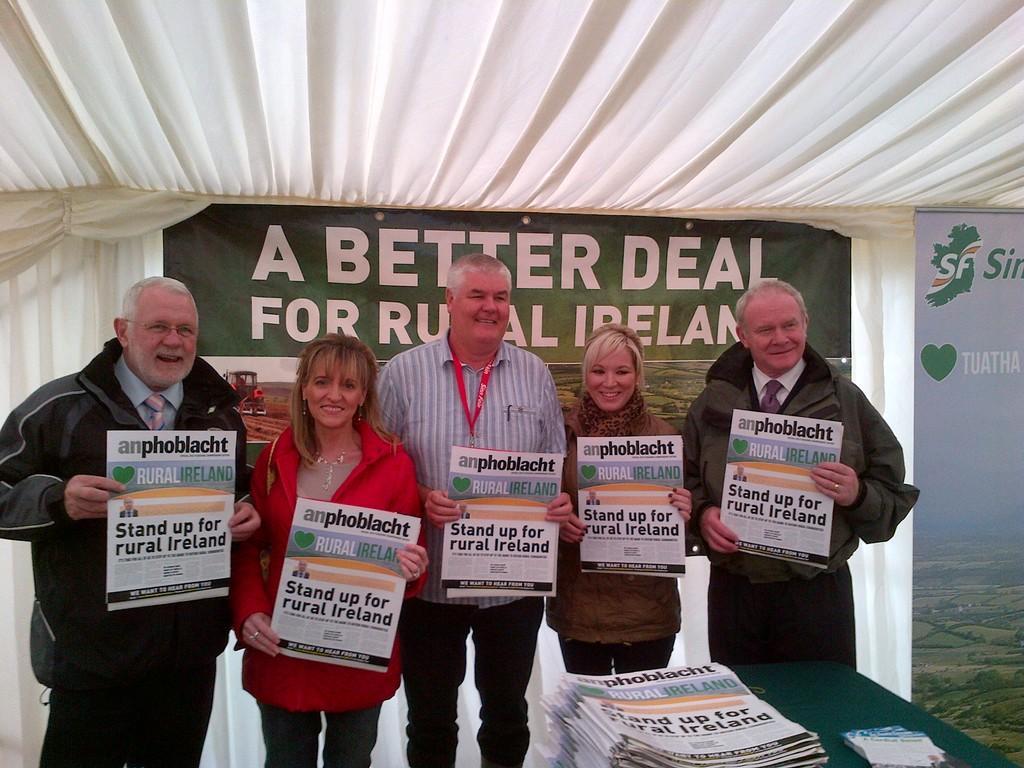In one or two sentences, can you explain what this image depicts? In this picture we can see some people are standing and holding the paper, in front there is a table on it so many papers are placed. 